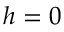Convert formula to latex. <formula><loc_0><loc_0><loc_500><loc_500>h = 0</formula> 